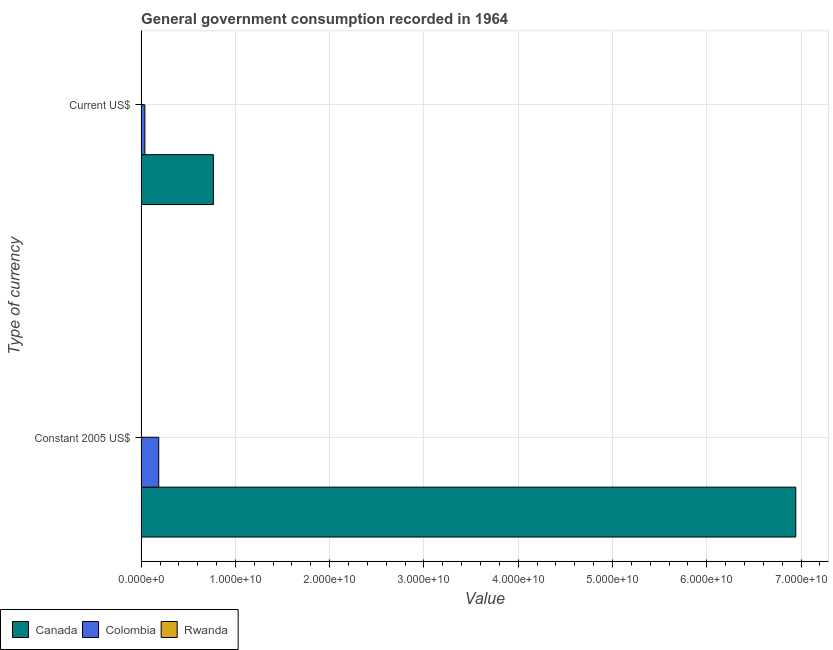Are the number of bars per tick equal to the number of legend labels?
Offer a terse response. Yes. Are the number of bars on each tick of the Y-axis equal?
Make the answer very short. Yes. How many bars are there on the 1st tick from the top?
Your answer should be very brief. 3. What is the label of the 1st group of bars from the top?
Your answer should be compact. Current US$. What is the value consumed in current us$ in Canada?
Your answer should be compact. 7.66e+09. Across all countries, what is the maximum value consumed in constant 2005 us$?
Offer a very short reply. 6.94e+1. Across all countries, what is the minimum value consumed in constant 2005 us$?
Make the answer very short. 3.53e+07. In which country was the value consumed in constant 2005 us$ maximum?
Offer a terse response. Canada. In which country was the value consumed in current us$ minimum?
Your answer should be very brief. Rwanda. What is the total value consumed in current us$ in the graph?
Provide a succinct answer. 8.08e+09. What is the difference between the value consumed in current us$ in Colombia and that in Rwanda?
Provide a succinct answer. 3.83e+08. What is the difference between the value consumed in current us$ in Rwanda and the value consumed in constant 2005 us$ in Canada?
Make the answer very short. -6.94e+1. What is the average value consumed in current us$ per country?
Provide a succinct answer. 2.69e+09. What is the difference between the value consumed in current us$ and value consumed in constant 2005 us$ in Rwanda?
Make the answer very short. -2.13e+07. What is the ratio of the value consumed in current us$ in Colombia to that in Rwanda?
Ensure brevity in your answer.  28.37. Is the value consumed in constant 2005 us$ in Canada less than that in Rwanda?
Your answer should be very brief. No. What does the 1st bar from the top in Current US$ represents?
Provide a short and direct response. Rwanda. What does the 3rd bar from the bottom in Constant 2005 US$ represents?
Make the answer very short. Rwanda. How many bars are there?
Your answer should be compact. 6. Are all the bars in the graph horizontal?
Your answer should be compact. Yes. How many countries are there in the graph?
Provide a short and direct response. 3. What is the difference between two consecutive major ticks on the X-axis?
Offer a very short reply. 1.00e+1. Does the graph contain grids?
Your answer should be very brief. Yes. How many legend labels are there?
Your answer should be compact. 3. What is the title of the graph?
Your response must be concise. General government consumption recorded in 1964. What is the label or title of the X-axis?
Give a very brief answer. Value. What is the label or title of the Y-axis?
Provide a short and direct response. Type of currency. What is the Value of Canada in Constant 2005 US$?
Give a very brief answer. 6.94e+1. What is the Value of Colombia in Constant 2005 US$?
Provide a short and direct response. 1.87e+09. What is the Value of Rwanda in Constant 2005 US$?
Provide a short and direct response. 3.53e+07. What is the Value of Canada in Current US$?
Your response must be concise. 7.66e+09. What is the Value of Colombia in Current US$?
Keep it short and to the point. 3.97e+08. What is the Value of Rwanda in Current US$?
Make the answer very short. 1.40e+07. Across all Type of currency, what is the maximum Value in Canada?
Make the answer very short. 6.94e+1. Across all Type of currency, what is the maximum Value of Colombia?
Your answer should be compact. 1.87e+09. Across all Type of currency, what is the maximum Value in Rwanda?
Offer a very short reply. 3.53e+07. Across all Type of currency, what is the minimum Value in Canada?
Your response must be concise. 7.66e+09. Across all Type of currency, what is the minimum Value in Colombia?
Make the answer very short. 3.97e+08. Across all Type of currency, what is the minimum Value of Rwanda?
Your response must be concise. 1.40e+07. What is the total Value in Canada in the graph?
Your answer should be very brief. 7.71e+1. What is the total Value in Colombia in the graph?
Give a very brief answer. 2.26e+09. What is the total Value of Rwanda in the graph?
Provide a short and direct response. 4.93e+07. What is the difference between the Value of Canada in Constant 2005 US$ and that in Current US$?
Provide a succinct answer. 6.18e+1. What is the difference between the Value of Colombia in Constant 2005 US$ and that in Current US$?
Your response must be concise. 1.47e+09. What is the difference between the Value of Rwanda in Constant 2005 US$ and that in Current US$?
Your response must be concise. 2.13e+07. What is the difference between the Value of Canada in Constant 2005 US$ and the Value of Colombia in Current US$?
Give a very brief answer. 6.90e+1. What is the difference between the Value in Canada in Constant 2005 US$ and the Value in Rwanda in Current US$?
Provide a succinct answer. 6.94e+1. What is the difference between the Value in Colombia in Constant 2005 US$ and the Value in Rwanda in Current US$?
Your answer should be compact. 1.85e+09. What is the average Value of Canada per Type of currency?
Your answer should be very brief. 3.86e+1. What is the average Value of Colombia per Type of currency?
Provide a succinct answer. 1.13e+09. What is the average Value of Rwanda per Type of currency?
Your answer should be very brief. 2.47e+07. What is the difference between the Value of Canada and Value of Colombia in Constant 2005 US$?
Your answer should be compact. 6.76e+1. What is the difference between the Value of Canada and Value of Rwanda in Constant 2005 US$?
Your answer should be very brief. 6.94e+1. What is the difference between the Value in Colombia and Value in Rwanda in Constant 2005 US$?
Offer a terse response. 1.83e+09. What is the difference between the Value of Canada and Value of Colombia in Current US$?
Offer a terse response. 7.27e+09. What is the difference between the Value in Canada and Value in Rwanda in Current US$?
Your answer should be very brief. 7.65e+09. What is the difference between the Value of Colombia and Value of Rwanda in Current US$?
Ensure brevity in your answer.  3.83e+08. What is the ratio of the Value in Canada in Constant 2005 US$ to that in Current US$?
Ensure brevity in your answer.  9.06. What is the ratio of the Value of Colombia in Constant 2005 US$ to that in Current US$?
Provide a short and direct response. 4.7. What is the ratio of the Value of Rwanda in Constant 2005 US$ to that in Current US$?
Offer a terse response. 2.52. What is the difference between the highest and the second highest Value of Canada?
Make the answer very short. 6.18e+1. What is the difference between the highest and the second highest Value of Colombia?
Offer a terse response. 1.47e+09. What is the difference between the highest and the second highest Value in Rwanda?
Provide a succinct answer. 2.13e+07. What is the difference between the highest and the lowest Value in Canada?
Offer a terse response. 6.18e+1. What is the difference between the highest and the lowest Value of Colombia?
Your answer should be very brief. 1.47e+09. What is the difference between the highest and the lowest Value in Rwanda?
Ensure brevity in your answer.  2.13e+07. 